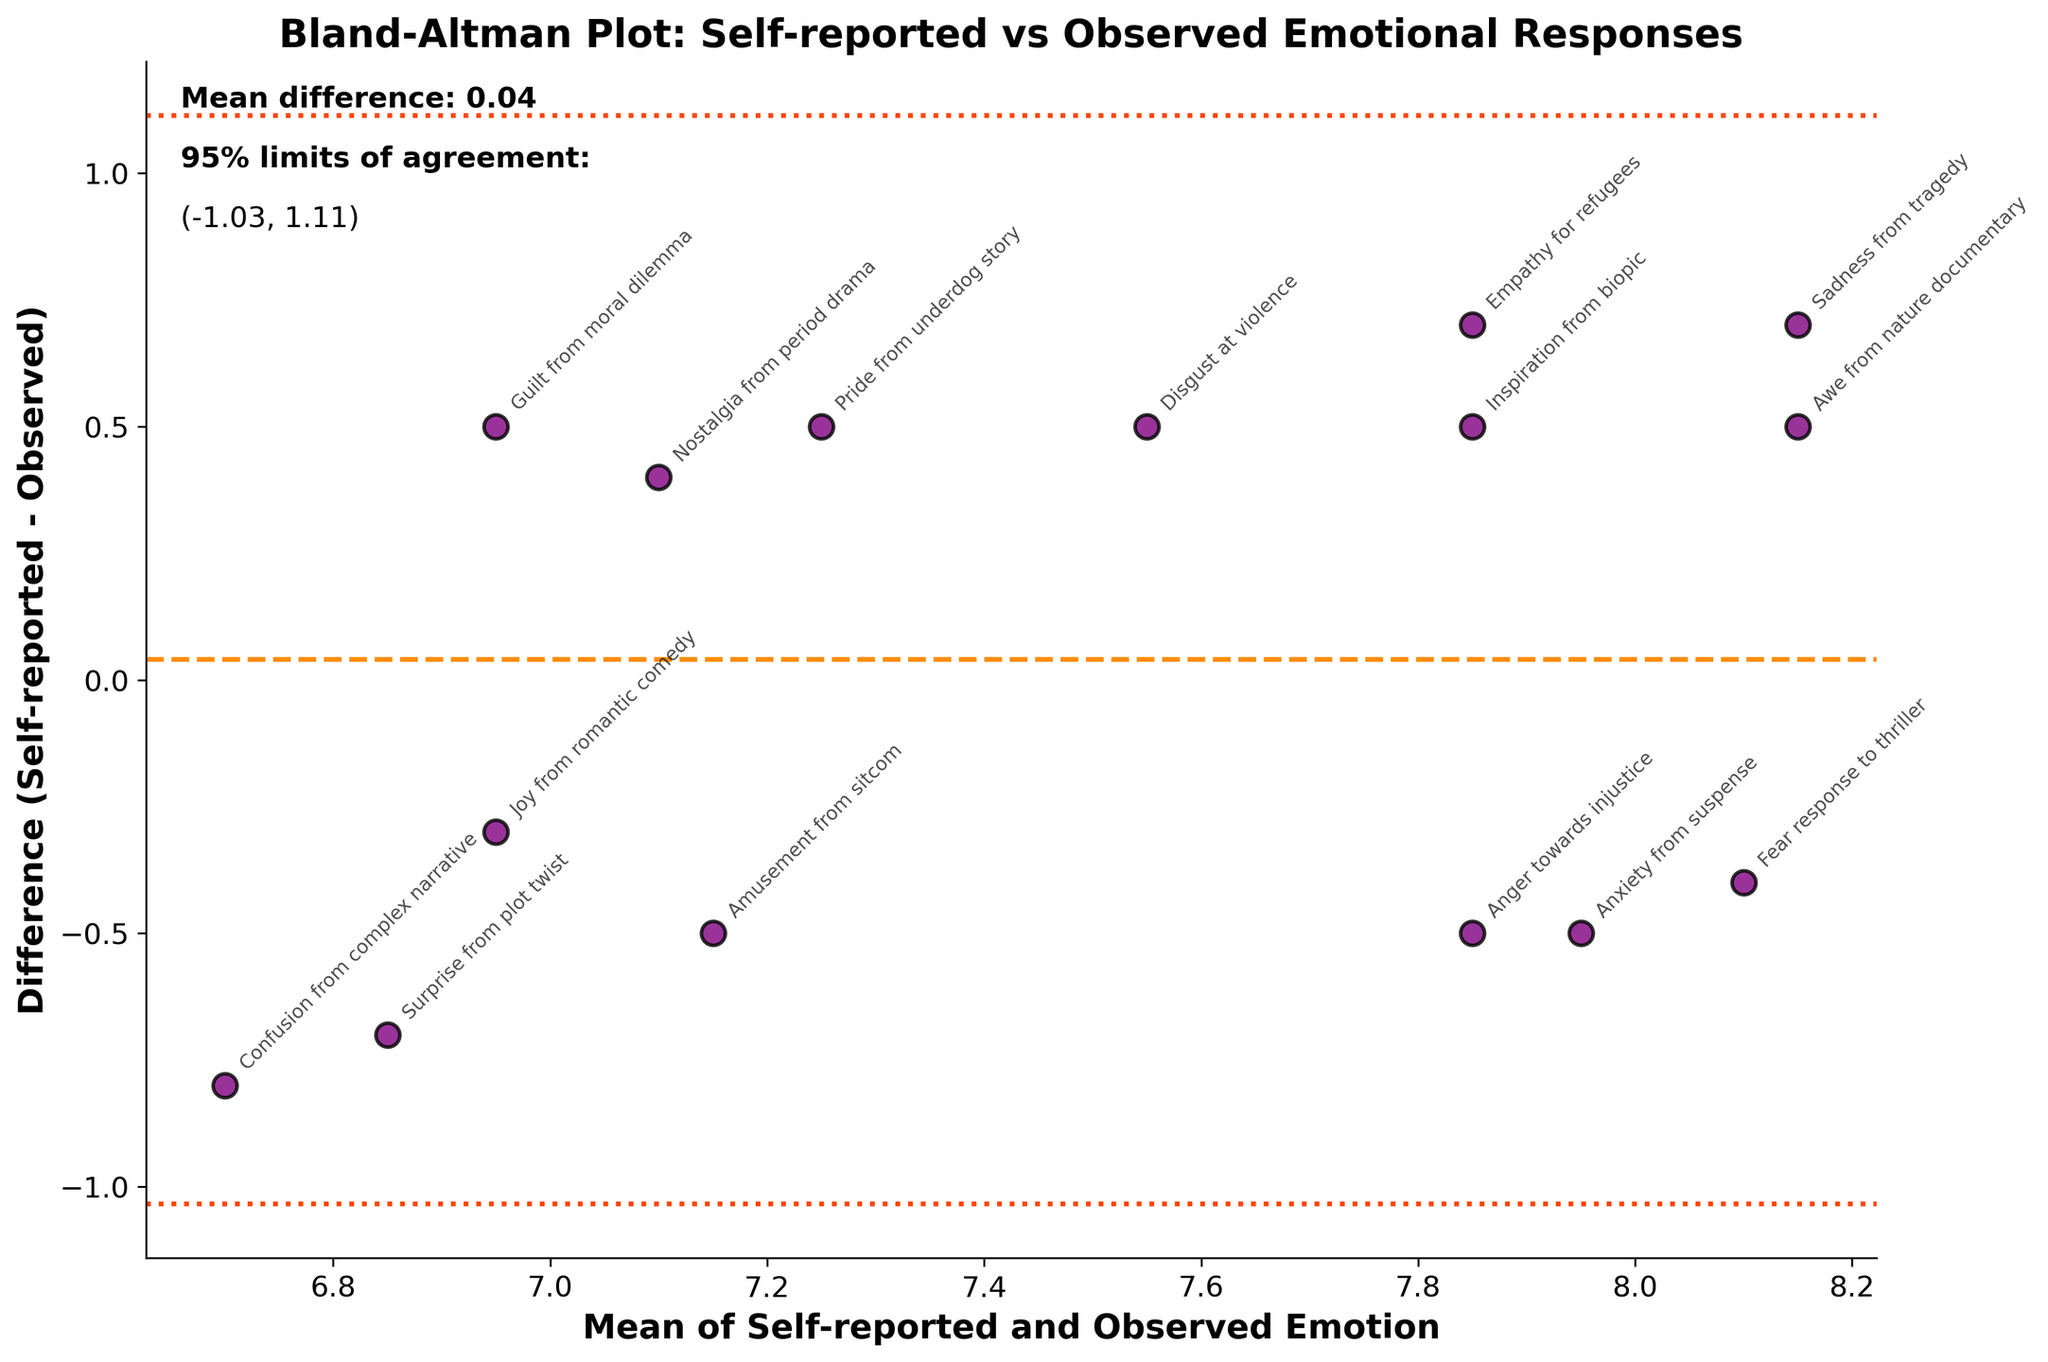what is the title of the plot? The title of the plot is located at the top of the figure. It provides an overview of what the figure represents. The title in this plot reads "Bland-Altman Plot: Self-reported vs Observed Emotional Responses."
Answer: Bland-Altman Plot: Self-reported vs Observed Emotional Responses How many data points are represented in the plot? The data points are represented by the number of subject labels and corresponding dots on the plot. Each dot corresponds to one set of self-reported and observed emotion responses. Counting the dots or the labels, we find that there are 15 data points.
Answer: 15 What is the color of the scatter points in the plot? The color of the scatter points can be identified by observing the dots on the plot. These points are primarily colored in purple.
Answer: purple What does the x-axis represent? The x-axis, labeled ‘Mean of Self-reported and Observed Emotion,’ represents the average of the self-reported and observed emotional responses for each subject.
Answer: Mean of Self-reported and Observed Emotion What does the y-axis represent? The y-axis, labeled ‘Difference (Self-reported - Observed),’ represents the difference between the self-reported and observed emotional responses for each subject.
Answer: Difference (Self-reported - Observed) Which subject shows the largest positive difference between Self-reported and Observed emotion? The largest positive difference can be found by observing the data point that is highest above the zero line on the y-axis. The subject with the most positive difference is "Confusion from complex narrative."
Answer: Confusion from complex narrative What are the limits of agreement in the plot? The limits of agreement are represented by the dashed lines above and below the mean difference line. They are calculated as mean difference ± 1.96 times the standard deviation. From the text annotation on the plot, the limits of agreement are approximately (-0.98, 0.58).
Answer: (-0.98, 0.58) What is the mean difference between Self-reported and Observed emotions? The mean difference is shown as a dashed line along the y-axis. The text annotation on the plot states the mean difference value, which is 0.20.
Answer: 0.20 For which subject is the mean of Self-reported and Observed emotion closest to 7? By finding the data point near the x-axis value of 7 and looking at the corresponding label, the subject closest to this value is "Nostalgia from period drama."
Answer: Nostalgia from period drama How do the Self-reported and Observed emotions for "Pride from underdog story" compare? The mean value on the x-axis and the difference on the y-axis for "Pride from underdog story" indicates how the self-reported value compares to the observed value. This data point falls below the zero line, indicating that the observed emotion is higher than the self-reported emotion.
Answer: Observed emotion is higher than Self-reported emotion 